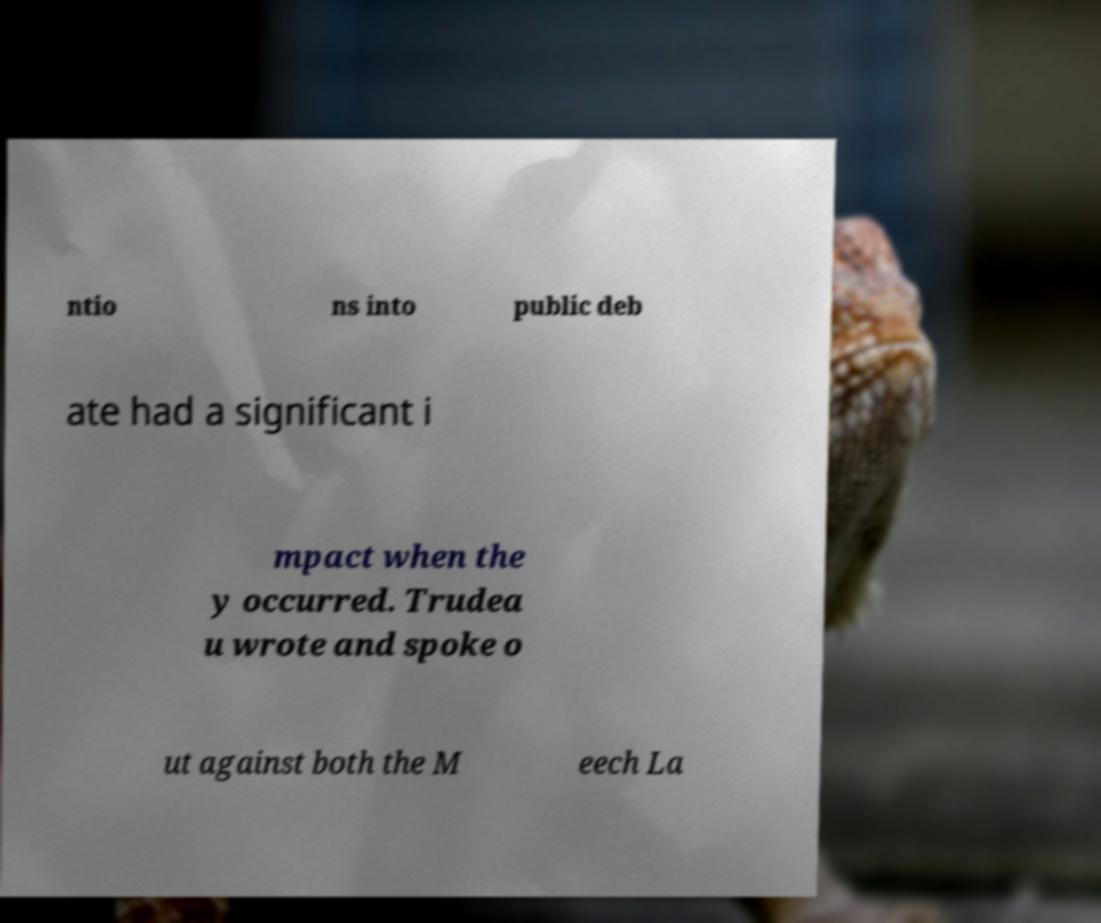Can you accurately transcribe the text from the provided image for me? ntio ns into public deb ate had a significant i mpact when the y occurred. Trudea u wrote and spoke o ut against both the M eech La 